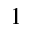Convert formula to latex. <formula><loc_0><loc_0><loc_500><loc_500>^ { 1 }</formula> 